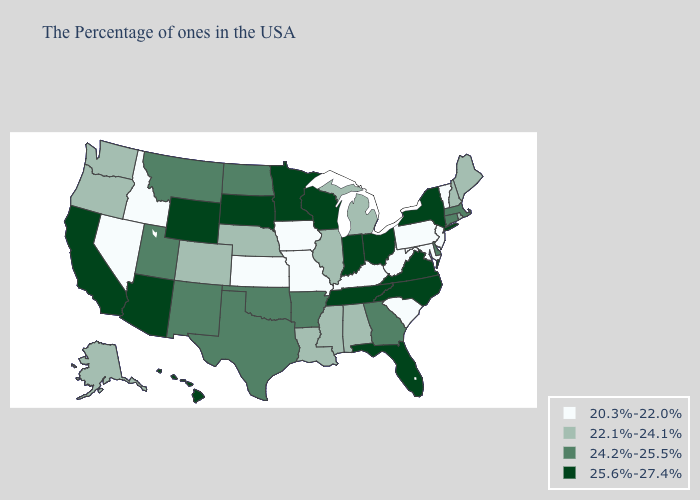What is the value of Arkansas?
Give a very brief answer. 24.2%-25.5%. What is the highest value in states that border Virginia?
Give a very brief answer. 25.6%-27.4%. Name the states that have a value in the range 25.6%-27.4%?
Write a very short answer. New York, Virginia, North Carolina, Ohio, Florida, Indiana, Tennessee, Wisconsin, Minnesota, South Dakota, Wyoming, Arizona, California, Hawaii. What is the lowest value in the MidWest?
Quick response, please. 20.3%-22.0%. Among the states that border Georgia , does Alabama have the lowest value?
Quick response, please. No. What is the highest value in the USA?
Be succinct. 25.6%-27.4%. Which states have the lowest value in the Northeast?
Give a very brief answer. Vermont, New Jersey, Pennsylvania. Name the states that have a value in the range 22.1%-24.1%?
Answer briefly. Maine, Rhode Island, New Hampshire, Michigan, Alabama, Illinois, Mississippi, Louisiana, Nebraska, Colorado, Washington, Oregon, Alaska. Is the legend a continuous bar?
Concise answer only. No. What is the value of Maryland?
Write a very short answer. 20.3%-22.0%. Does Wisconsin have the highest value in the MidWest?
Keep it brief. Yes. Name the states that have a value in the range 20.3%-22.0%?
Short answer required. Vermont, New Jersey, Maryland, Pennsylvania, South Carolina, West Virginia, Kentucky, Missouri, Iowa, Kansas, Idaho, Nevada. What is the lowest value in the Northeast?
Short answer required. 20.3%-22.0%. What is the lowest value in the USA?
Write a very short answer. 20.3%-22.0%. What is the lowest value in states that border Missouri?
Short answer required. 20.3%-22.0%. 